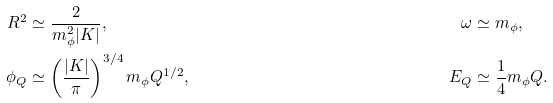Convert formula to latex. <formula><loc_0><loc_0><loc_500><loc_500>R ^ { 2 } & \simeq \frac { 2 } { m _ { \phi } ^ { 2 } | K | } , & \omega & \simeq m _ { \phi } , \\ \phi _ { Q } & \simeq \left ( \frac { | K | } { \pi } \right ) ^ { 3 / 4 } m _ { \phi } Q ^ { 1 / 2 } , & E _ { Q } & \simeq \frac { 1 } { 4 } m _ { \phi } Q .</formula> 